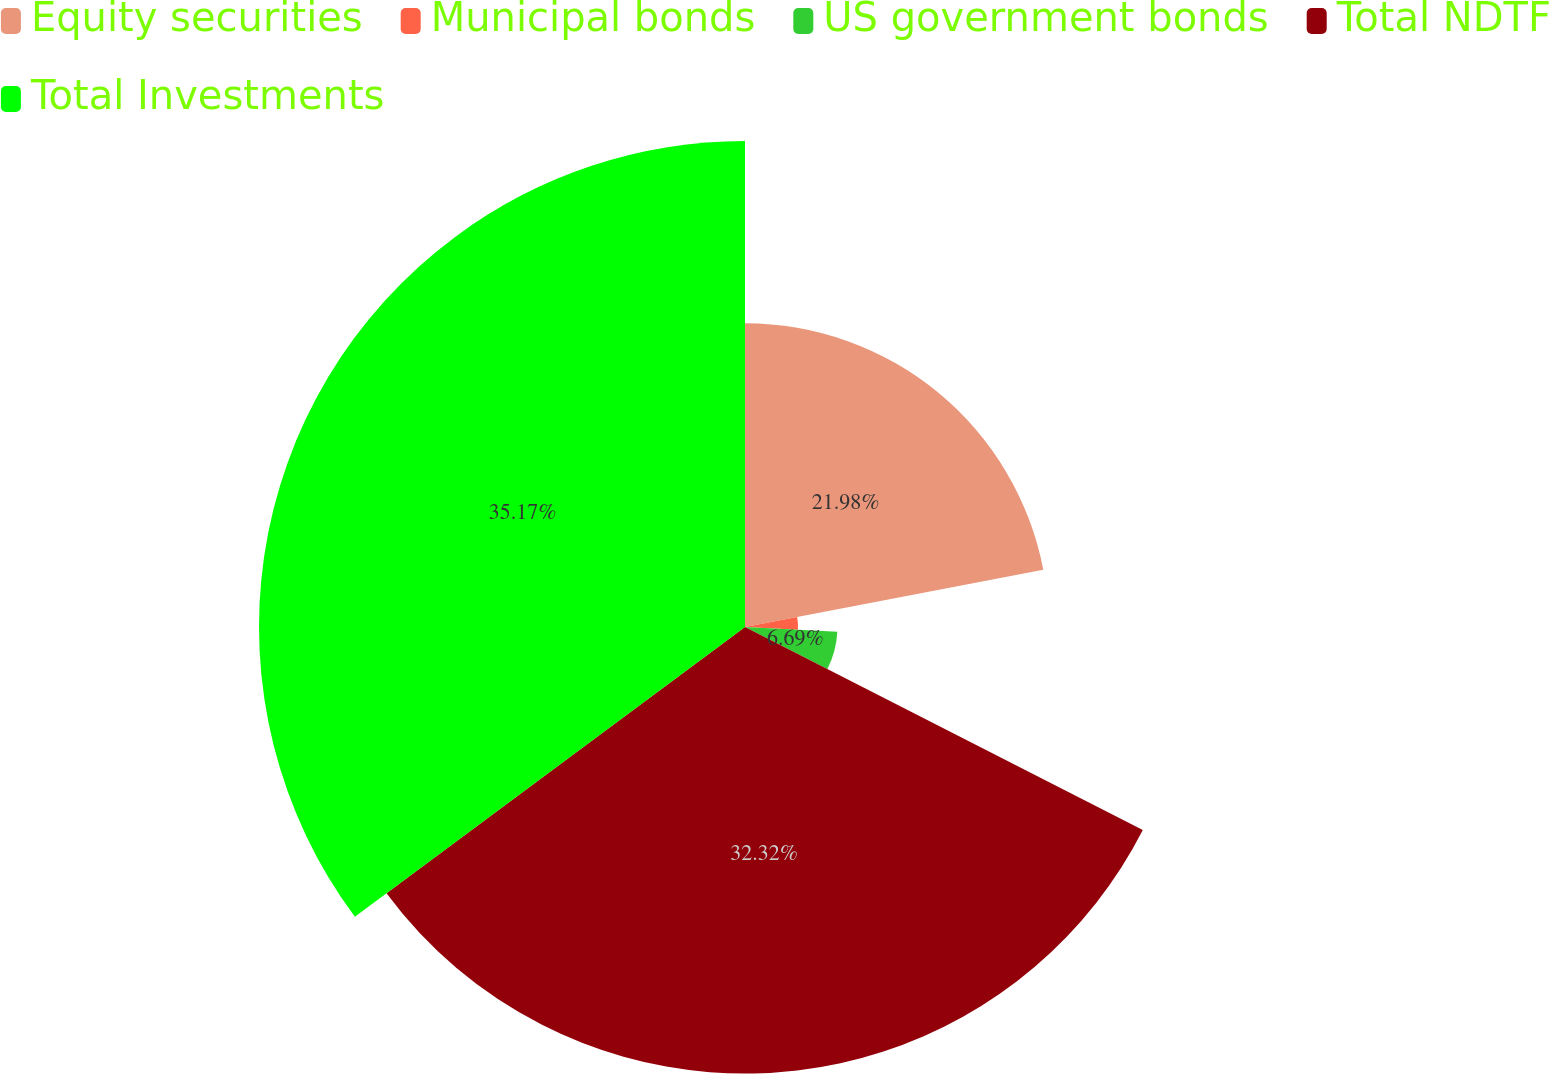Convert chart. <chart><loc_0><loc_0><loc_500><loc_500><pie_chart><fcel>Equity securities<fcel>Municipal bonds<fcel>US government bonds<fcel>Total NDTF<fcel>Total Investments<nl><fcel>21.98%<fcel>3.84%<fcel>6.69%<fcel>32.32%<fcel>35.17%<nl></chart> 